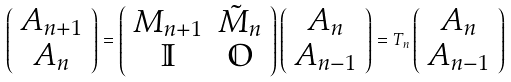<formula> <loc_0><loc_0><loc_500><loc_500>\left ( \begin{array} { c c } A _ { n + 1 } \\ A _ { n } \\ \end{array} \right ) = \left ( \begin{array} { c c } M _ { n + 1 } & \tilde { M } _ { n } \\ \mathbb { I } & \mathbb { O } \\ \end{array} \right ) \left ( \begin{array} { c c } A _ { n } \\ A _ { n - 1 } \\ \end{array} \right ) = T _ { n } \left ( \begin{array} { c c } A _ { n } \\ A _ { n - 1 } \\ \end{array} \right )</formula> 